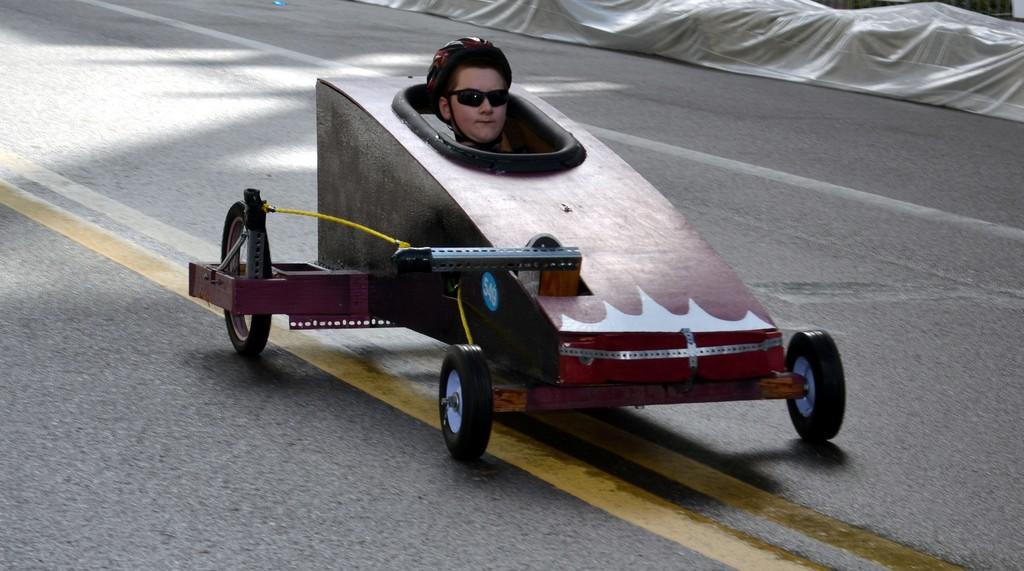Who or what can be seen inside the vehicle in the image? There is a person visible in the vehicle. Where is the vehicle located in the image? The vehicle is on the road. What is present in the top right corner of the image? There is a white color cloth in the top right corner of the image. What is the opinion of the person in the vehicle about the match they are watching? There is no information about a match or the person's opinion in the image. --- Facts: 1. There is a person sitting on a bench. 2. The person is reading a book. 3. There is a tree behind the bench. 4. The sky is visible in the image. Absurd Topics: dance, ocean, parrot Conversation: What is the person on the bench doing in the image? The person is sitting on a bench and reading a book. What is located behind the bench in the image? There is a tree behind the bench. What can be seen in the sky in the image? The sky is visible in the image. Reasoning: Let's think step by step in order to produce the conversation. We start by identifying the main subject in the image, which is the person sitting on the bench. Then, we expand the conversation to include the person's activity (reading a book) and the presence of the tree and sky in the image. Each question is designed to elicit a specific detail about the image that is known from the provided facts. Absurd Question/Answer: Can you see any parrots flying over the ocean in the image? There is no ocean or parrots present in the image. 